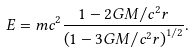<formula> <loc_0><loc_0><loc_500><loc_500>E = m c ^ { 2 } \frac { 1 - 2 G M / c ^ { 2 } r } { \left ( 1 - 3 G M / c ^ { 2 } r \right ) ^ { 1 / 2 } } .</formula> 